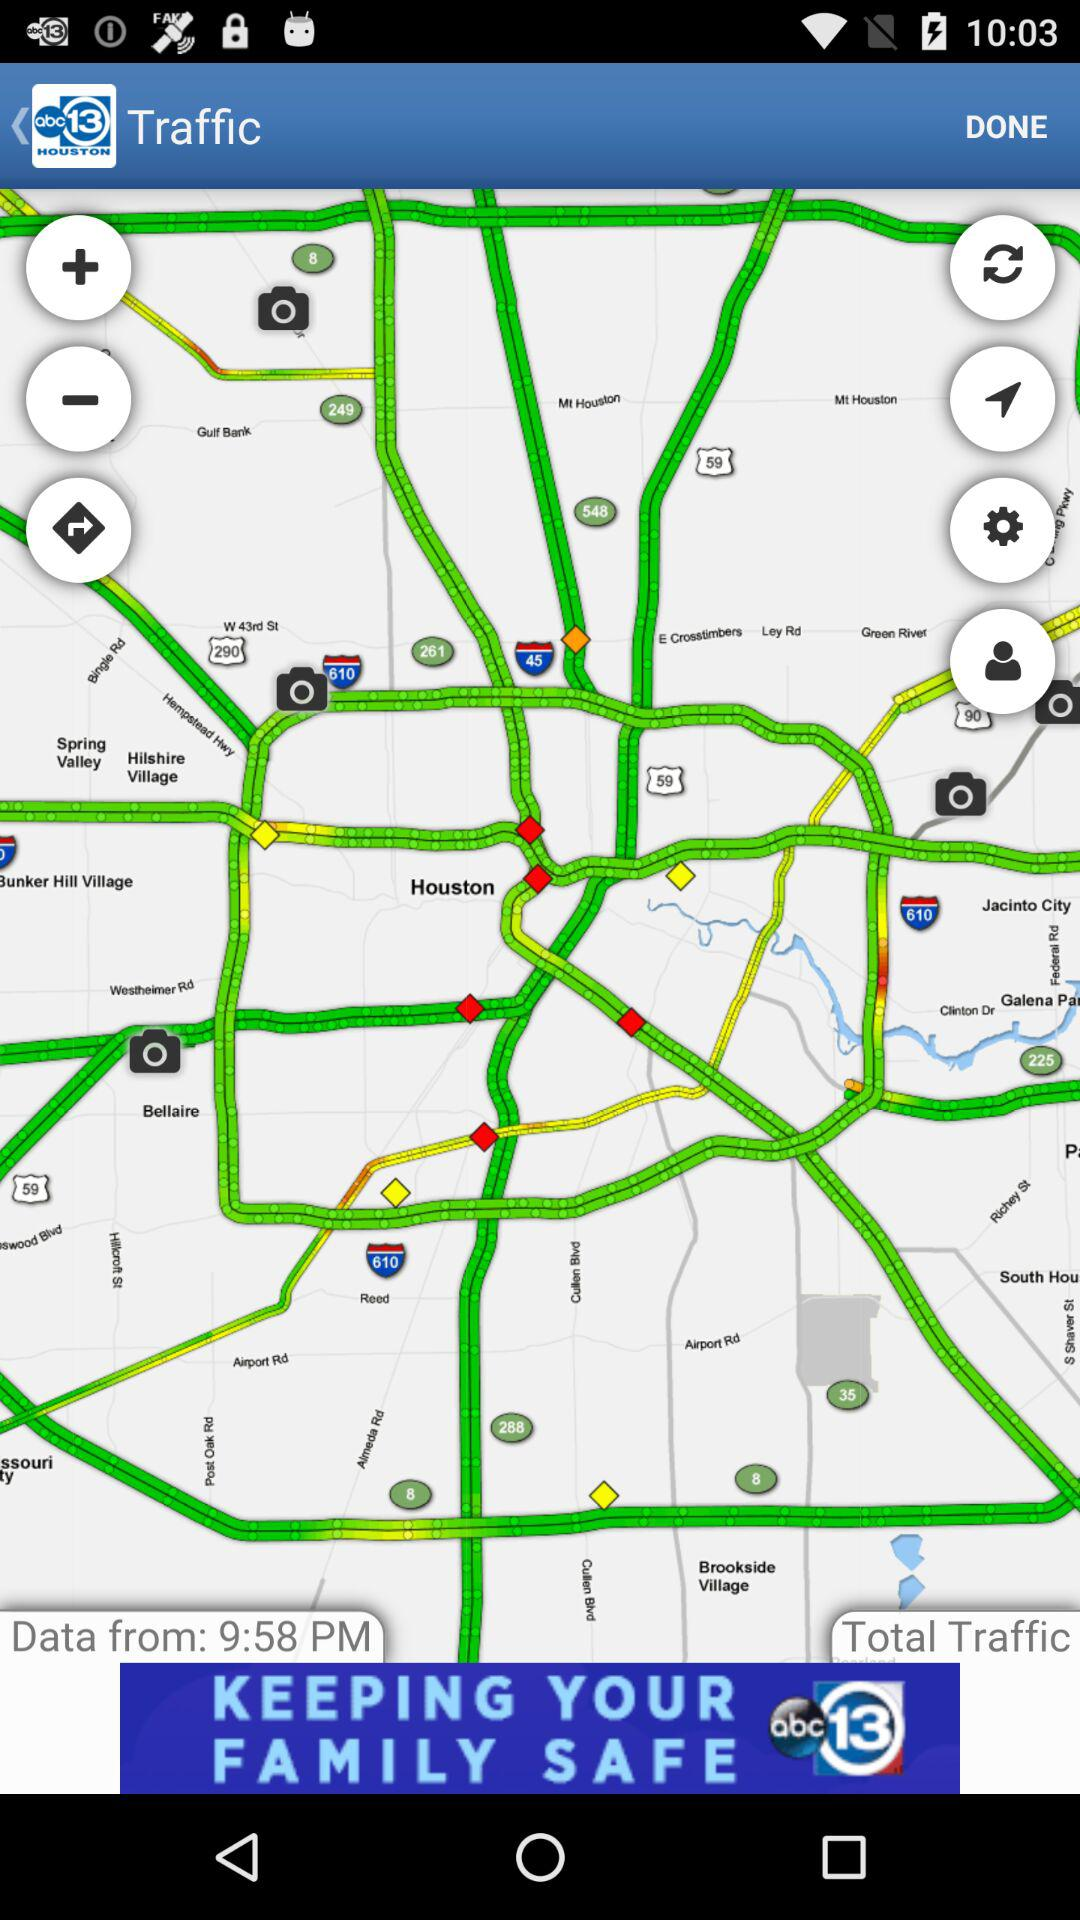What is the name of the application? The name of the application is "abc13 HOUSTON". 